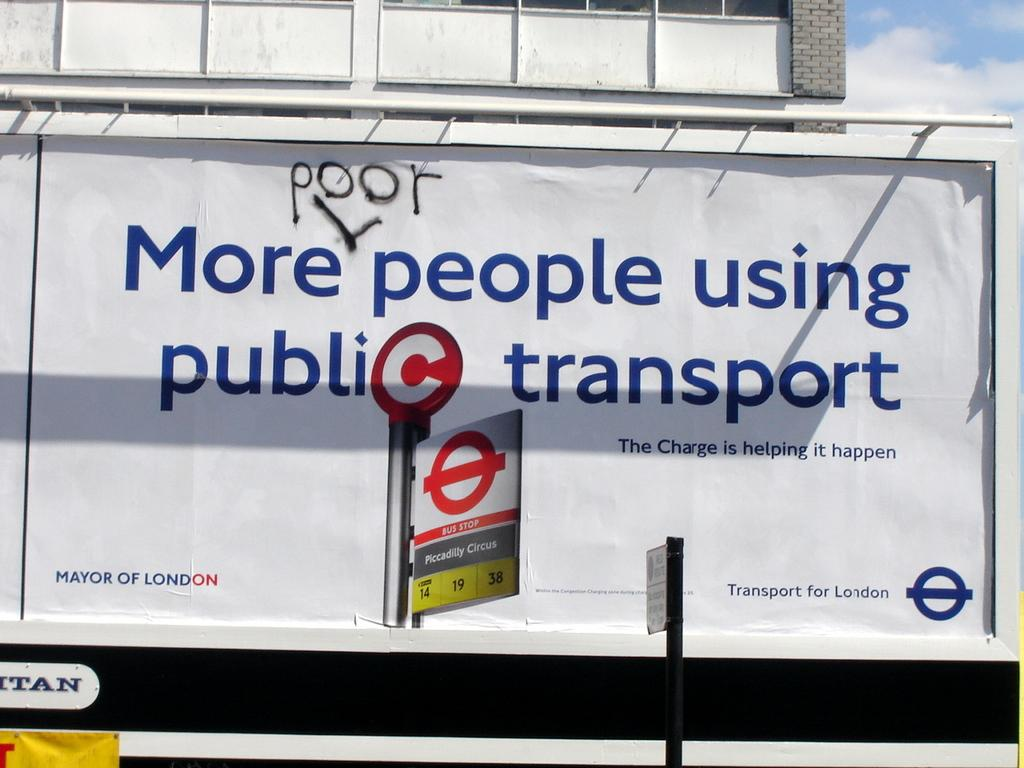What is the main subject of the image? The main subject of the image is a hoarding. What can be seen on the hoarding? There is writing on the hoarding. What part of the sky is visible in the image? The sky is visible in the top right corner of the image. Can you see a ghost holding a cake and a clover in the image? No, there is no ghost, cake, or clover present in the image. 